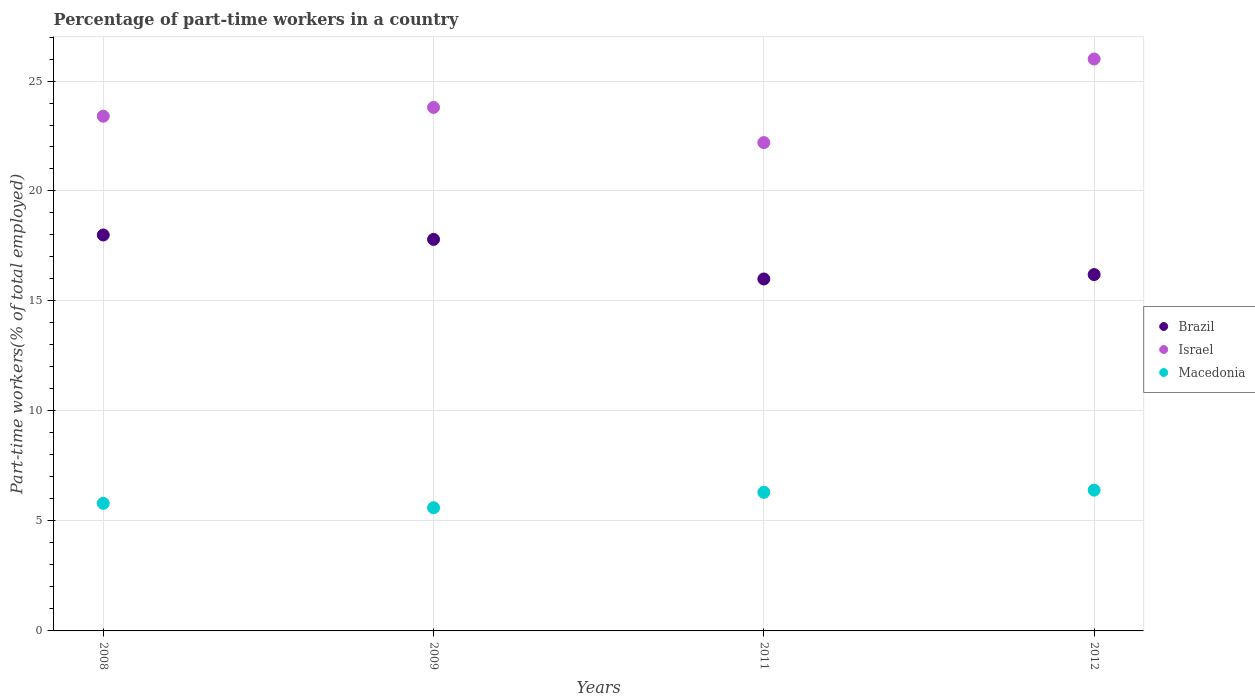Is the number of dotlines equal to the number of legend labels?
Offer a very short reply. Yes. What is the percentage of part-time workers in Israel in 2009?
Provide a short and direct response. 23.8. Across all years, what is the maximum percentage of part-time workers in Macedonia?
Provide a succinct answer. 6.4. Across all years, what is the minimum percentage of part-time workers in Israel?
Provide a short and direct response. 22.2. In which year was the percentage of part-time workers in Brazil minimum?
Your answer should be compact. 2011. What is the total percentage of part-time workers in Brazil in the graph?
Provide a short and direct response. 68. What is the difference between the percentage of part-time workers in Israel in 2011 and that in 2012?
Offer a very short reply. -3.8. What is the difference between the percentage of part-time workers in Israel in 2011 and the percentage of part-time workers in Brazil in 2008?
Your response must be concise. 4.2. What is the average percentage of part-time workers in Macedonia per year?
Offer a terse response. 6.03. In the year 2012, what is the difference between the percentage of part-time workers in Brazil and percentage of part-time workers in Israel?
Your answer should be very brief. -9.8. What is the ratio of the percentage of part-time workers in Israel in 2011 to that in 2012?
Provide a succinct answer. 0.85. What is the difference between the highest and the second highest percentage of part-time workers in Macedonia?
Your response must be concise. 0.1. What is the difference between the highest and the lowest percentage of part-time workers in Macedonia?
Your answer should be very brief. 0.8. Is it the case that in every year, the sum of the percentage of part-time workers in Macedonia and percentage of part-time workers in Israel  is greater than the percentage of part-time workers in Brazil?
Your response must be concise. Yes. What is the difference between two consecutive major ticks on the Y-axis?
Make the answer very short. 5. Does the graph contain any zero values?
Keep it short and to the point. No. Where does the legend appear in the graph?
Your answer should be very brief. Center right. How many legend labels are there?
Provide a succinct answer. 3. What is the title of the graph?
Your response must be concise. Percentage of part-time workers in a country. Does "Middle income" appear as one of the legend labels in the graph?
Ensure brevity in your answer.  No. What is the label or title of the X-axis?
Your response must be concise. Years. What is the label or title of the Y-axis?
Offer a terse response. Part-time workers(% of total employed). What is the Part-time workers(% of total employed) of Brazil in 2008?
Provide a succinct answer. 18. What is the Part-time workers(% of total employed) of Israel in 2008?
Provide a short and direct response. 23.4. What is the Part-time workers(% of total employed) of Macedonia in 2008?
Your answer should be very brief. 5.8. What is the Part-time workers(% of total employed) in Brazil in 2009?
Make the answer very short. 17.8. What is the Part-time workers(% of total employed) in Israel in 2009?
Offer a terse response. 23.8. What is the Part-time workers(% of total employed) in Macedonia in 2009?
Make the answer very short. 5.6. What is the Part-time workers(% of total employed) of Israel in 2011?
Your answer should be very brief. 22.2. What is the Part-time workers(% of total employed) of Macedonia in 2011?
Provide a succinct answer. 6.3. What is the Part-time workers(% of total employed) in Brazil in 2012?
Offer a very short reply. 16.2. What is the Part-time workers(% of total employed) in Israel in 2012?
Give a very brief answer. 26. What is the Part-time workers(% of total employed) of Macedonia in 2012?
Your response must be concise. 6.4. Across all years, what is the maximum Part-time workers(% of total employed) of Brazil?
Offer a terse response. 18. Across all years, what is the maximum Part-time workers(% of total employed) of Macedonia?
Your answer should be very brief. 6.4. Across all years, what is the minimum Part-time workers(% of total employed) in Brazil?
Provide a short and direct response. 16. Across all years, what is the minimum Part-time workers(% of total employed) in Israel?
Give a very brief answer. 22.2. Across all years, what is the minimum Part-time workers(% of total employed) in Macedonia?
Ensure brevity in your answer.  5.6. What is the total Part-time workers(% of total employed) of Israel in the graph?
Provide a short and direct response. 95.4. What is the total Part-time workers(% of total employed) in Macedonia in the graph?
Your answer should be compact. 24.1. What is the difference between the Part-time workers(% of total employed) in Macedonia in 2008 and that in 2009?
Keep it short and to the point. 0.2. What is the difference between the Part-time workers(% of total employed) of Macedonia in 2008 and that in 2011?
Provide a succinct answer. -0.5. What is the difference between the Part-time workers(% of total employed) in Brazil in 2008 and that in 2012?
Keep it short and to the point. 1.8. What is the difference between the Part-time workers(% of total employed) in Israel in 2008 and that in 2012?
Make the answer very short. -2.6. What is the difference between the Part-time workers(% of total employed) of Brazil in 2009 and that in 2011?
Offer a very short reply. 1.8. What is the difference between the Part-time workers(% of total employed) of Macedonia in 2009 and that in 2011?
Offer a very short reply. -0.7. What is the difference between the Part-time workers(% of total employed) in Israel in 2009 and that in 2012?
Your response must be concise. -2.2. What is the difference between the Part-time workers(% of total employed) in Macedonia in 2009 and that in 2012?
Ensure brevity in your answer.  -0.8. What is the difference between the Part-time workers(% of total employed) of Israel in 2011 and that in 2012?
Your response must be concise. -3.8. What is the difference between the Part-time workers(% of total employed) in Brazil in 2008 and the Part-time workers(% of total employed) in Israel in 2009?
Provide a succinct answer. -5.8. What is the difference between the Part-time workers(% of total employed) in Brazil in 2008 and the Part-time workers(% of total employed) in Macedonia in 2009?
Provide a short and direct response. 12.4. What is the difference between the Part-time workers(% of total employed) in Israel in 2008 and the Part-time workers(% of total employed) in Macedonia in 2009?
Keep it short and to the point. 17.8. What is the difference between the Part-time workers(% of total employed) in Brazil in 2008 and the Part-time workers(% of total employed) in Israel in 2011?
Make the answer very short. -4.2. What is the difference between the Part-time workers(% of total employed) in Israel in 2008 and the Part-time workers(% of total employed) in Macedonia in 2011?
Provide a short and direct response. 17.1. What is the difference between the Part-time workers(% of total employed) in Brazil in 2008 and the Part-time workers(% of total employed) in Israel in 2012?
Keep it short and to the point. -8. What is the difference between the Part-time workers(% of total employed) in Brazil in 2008 and the Part-time workers(% of total employed) in Macedonia in 2012?
Offer a terse response. 11.6. What is the difference between the Part-time workers(% of total employed) of Israel in 2008 and the Part-time workers(% of total employed) of Macedonia in 2012?
Your answer should be very brief. 17. What is the difference between the Part-time workers(% of total employed) of Brazil in 2009 and the Part-time workers(% of total employed) of Israel in 2011?
Keep it short and to the point. -4.4. What is the difference between the Part-time workers(% of total employed) of Brazil in 2011 and the Part-time workers(% of total employed) of Macedonia in 2012?
Offer a terse response. 9.6. What is the average Part-time workers(% of total employed) in Israel per year?
Your answer should be compact. 23.85. What is the average Part-time workers(% of total employed) in Macedonia per year?
Your answer should be very brief. 6.03. In the year 2008, what is the difference between the Part-time workers(% of total employed) in Brazil and Part-time workers(% of total employed) in Israel?
Make the answer very short. -5.4. In the year 2008, what is the difference between the Part-time workers(% of total employed) in Israel and Part-time workers(% of total employed) in Macedonia?
Your answer should be compact. 17.6. In the year 2009, what is the difference between the Part-time workers(% of total employed) of Israel and Part-time workers(% of total employed) of Macedonia?
Your answer should be very brief. 18.2. In the year 2011, what is the difference between the Part-time workers(% of total employed) of Brazil and Part-time workers(% of total employed) of Israel?
Make the answer very short. -6.2. In the year 2011, what is the difference between the Part-time workers(% of total employed) of Brazil and Part-time workers(% of total employed) of Macedonia?
Provide a succinct answer. 9.7. In the year 2012, what is the difference between the Part-time workers(% of total employed) in Brazil and Part-time workers(% of total employed) in Israel?
Your answer should be compact. -9.8. In the year 2012, what is the difference between the Part-time workers(% of total employed) in Israel and Part-time workers(% of total employed) in Macedonia?
Your answer should be compact. 19.6. What is the ratio of the Part-time workers(% of total employed) of Brazil in 2008 to that in 2009?
Offer a very short reply. 1.01. What is the ratio of the Part-time workers(% of total employed) in Israel in 2008 to that in 2009?
Give a very brief answer. 0.98. What is the ratio of the Part-time workers(% of total employed) in Macedonia in 2008 to that in 2009?
Your response must be concise. 1.04. What is the ratio of the Part-time workers(% of total employed) in Brazil in 2008 to that in 2011?
Ensure brevity in your answer.  1.12. What is the ratio of the Part-time workers(% of total employed) of Israel in 2008 to that in 2011?
Provide a succinct answer. 1.05. What is the ratio of the Part-time workers(% of total employed) in Macedonia in 2008 to that in 2011?
Ensure brevity in your answer.  0.92. What is the ratio of the Part-time workers(% of total employed) in Brazil in 2008 to that in 2012?
Give a very brief answer. 1.11. What is the ratio of the Part-time workers(% of total employed) of Israel in 2008 to that in 2012?
Ensure brevity in your answer.  0.9. What is the ratio of the Part-time workers(% of total employed) of Macedonia in 2008 to that in 2012?
Your answer should be compact. 0.91. What is the ratio of the Part-time workers(% of total employed) of Brazil in 2009 to that in 2011?
Your response must be concise. 1.11. What is the ratio of the Part-time workers(% of total employed) in Israel in 2009 to that in 2011?
Your answer should be very brief. 1.07. What is the ratio of the Part-time workers(% of total employed) of Macedonia in 2009 to that in 2011?
Your answer should be compact. 0.89. What is the ratio of the Part-time workers(% of total employed) in Brazil in 2009 to that in 2012?
Ensure brevity in your answer.  1.1. What is the ratio of the Part-time workers(% of total employed) of Israel in 2009 to that in 2012?
Make the answer very short. 0.92. What is the ratio of the Part-time workers(% of total employed) of Brazil in 2011 to that in 2012?
Provide a short and direct response. 0.99. What is the ratio of the Part-time workers(% of total employed) in Israel in 2011 to that in 2012?
Provide a short and direct response. 0.85. What is the ratio of the Part-time workers(% of total employed) in Macedonia in 2011 to that in 2012?
Your response must be concise. 0.98. What is the difference between the highest and the second highest Part-time workers(% of total employed) in Brazil?
Give a very brief answer. 0.2. What is the difference between the highest and the second highest Part-time workers(% of total employed) of Israel?
Your answer should be compact. 2.2. What is the difference between the highest and the second highest Part-time workers(% of total employed) in Macedonia?
Make the answer very short. 0.1. What is the difference between the highest and the lowest Part-time workers(% of total employed) in Brazil?
Offer a very short reply. 2. What is the difference between the highest and the lowest Part-time workers(% of total employed) of Israel?
Ensure brevity in your answer.  3.8. What is the difference between the highest and the lowest Part-time workers(% of total employed) of Macedonia?
Your answer should be very brief. 0.8. 